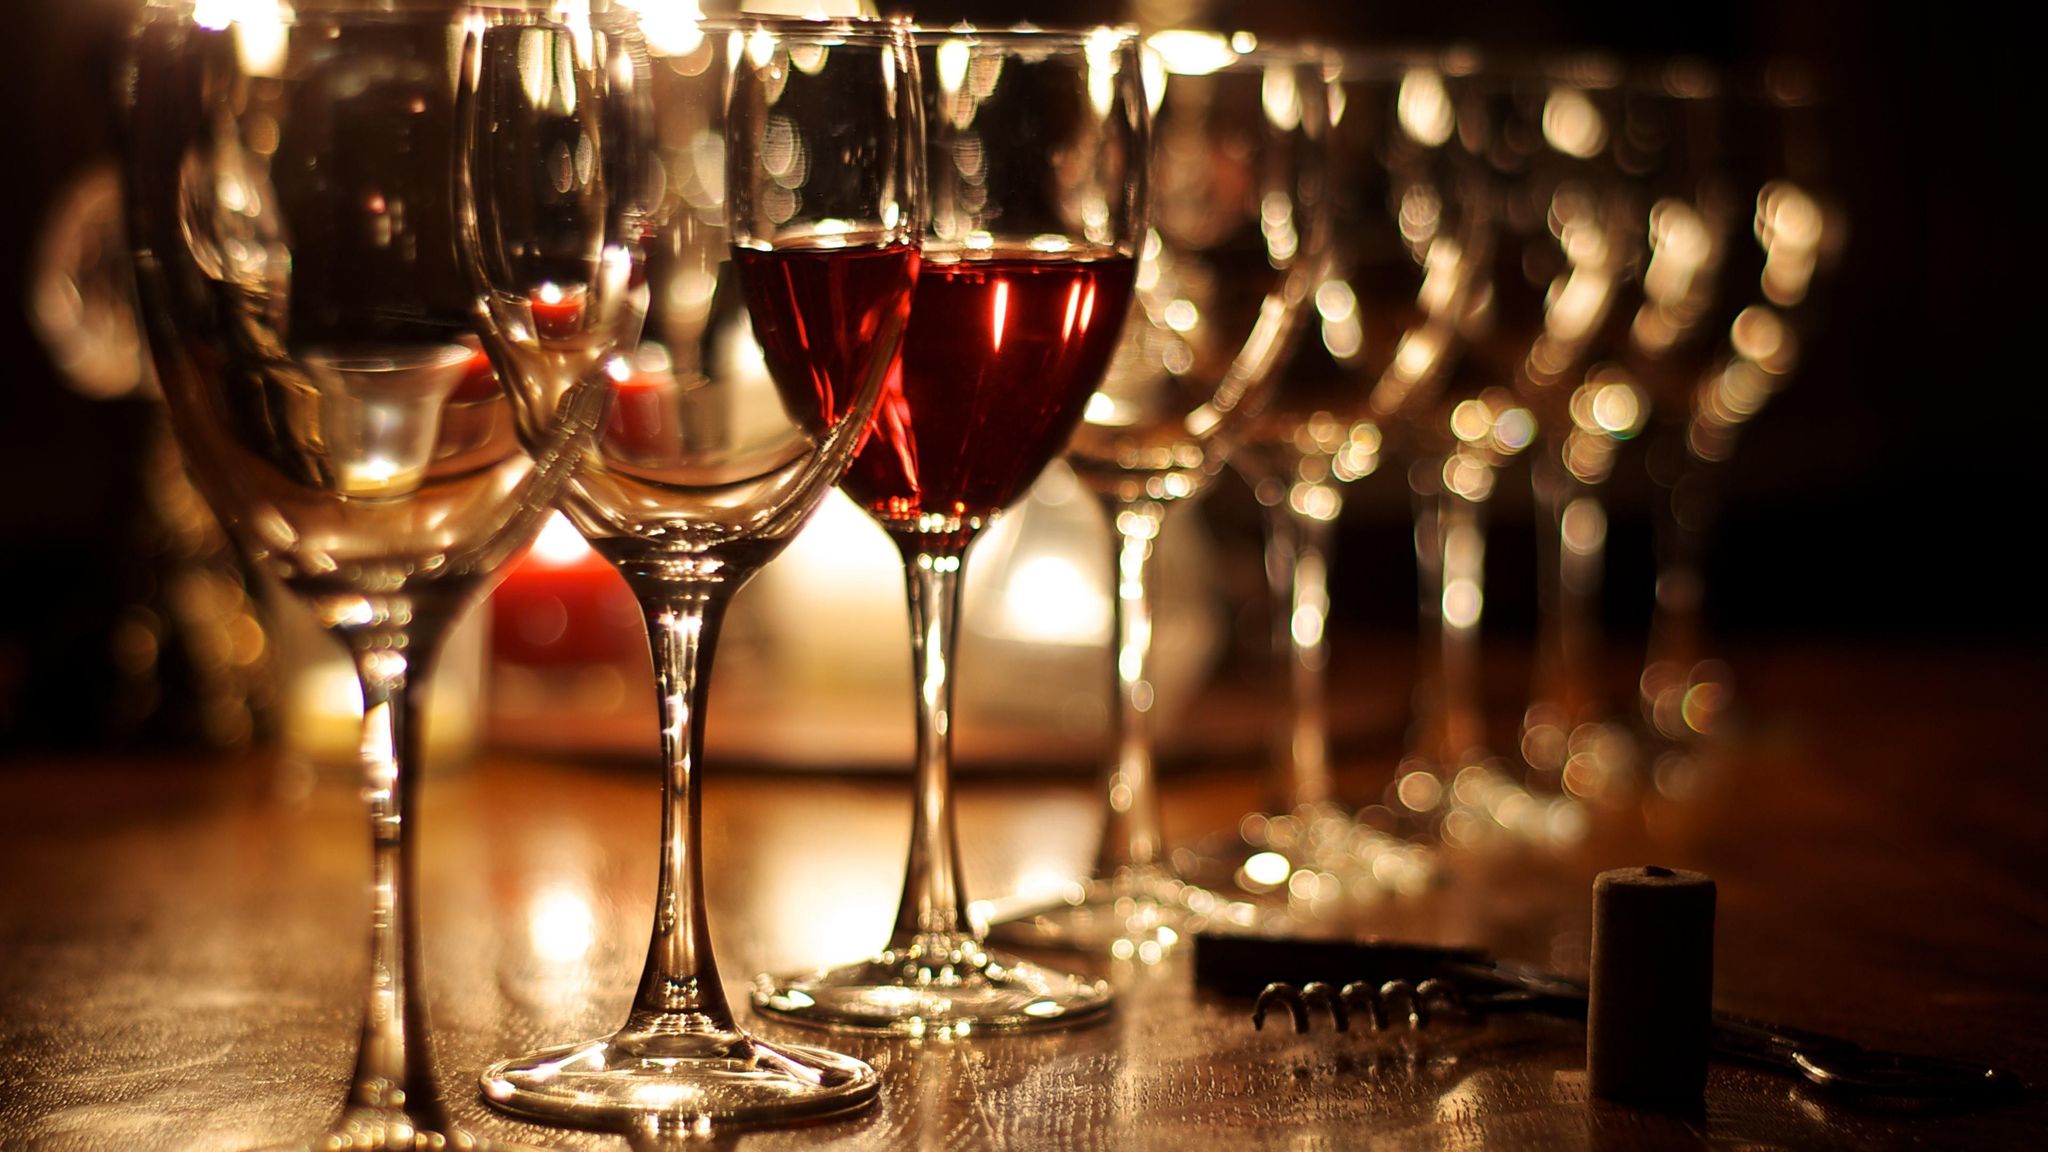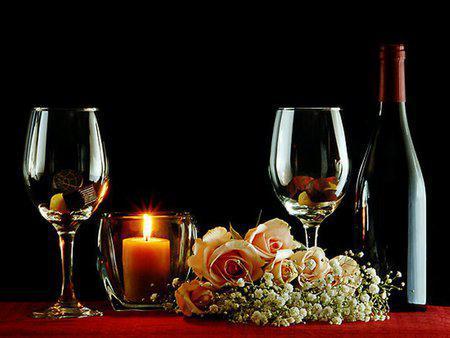The first image is the image on the left, the second image is the image on the right. Considering the images on both sides, is "There is an obvious fireplace in the background of one of the images." valid? Answer yes or no. No. The first image is the image on the left, the second image is the image on the right. For the images displayed, is the sentence "there are four wine glasses total in both" factually correct? Answer yes or no. No. 